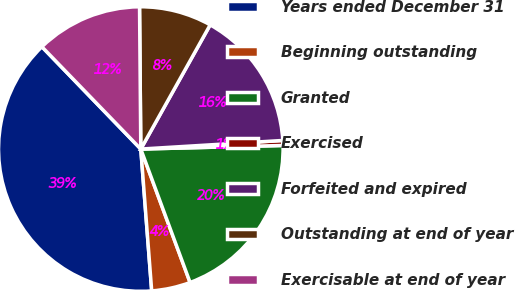<chart> <loc_0><loc_0><loc_500><loc_500><pie_chart><fcel>Years ended December 31<fcel>Beginning outstanding<fcel>Granted<fcel>Exercised<fcel>Forfeited and expired<fcel>Outstanding at end of year<fcel>Exercisable at end of year<nl><fcel>38.99%<fcel>4.41%<fcel>19.77%<fcel>0.56%<fcel>15.93%<fcel>8.25%<fcel>12.09%<nl></chart> 